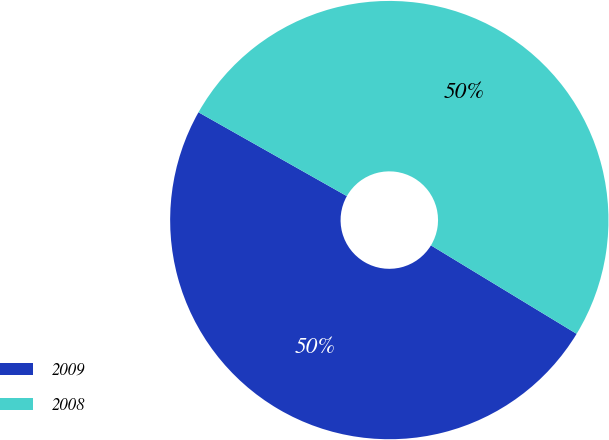Convert chart to OTSL. <chart><loc_0><loc_0><loc_500><loc_500><pie_chart><fcel>2009<fcel>2008<nl><fcel>49.5%<fcel>50.5%<nl></chart> 